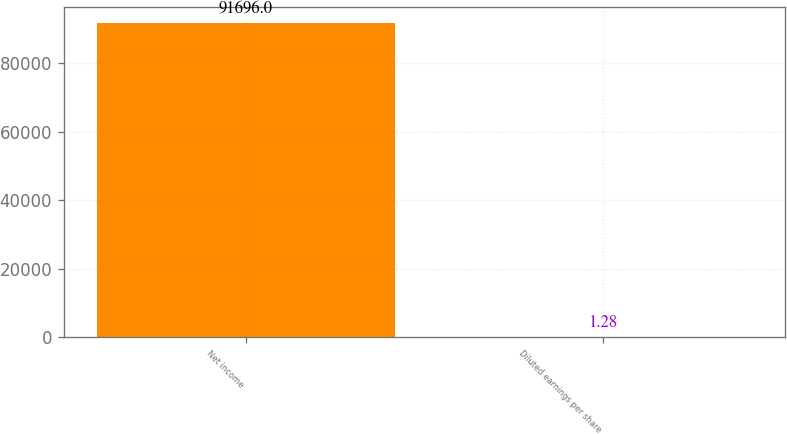Convert chart. <chart><loc_0><loc_0><loc_500><loc_500><bar_chart><fcel>Net income<fcel>Diluted earnings per share<nl><fcel>91696<fcel>1.28<nl></chart> 